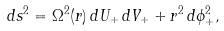Convert formula to latex. <formula><loc_0><loc_0><loc_500><loc_500>d s ^ { 2 } = \Omega ^ { 2 } ( r ) \, d U _ { + } \, d V _ { + } + r ^ { 2 } \, d \phi _ { + } ^ { 2 } ,</formula> 